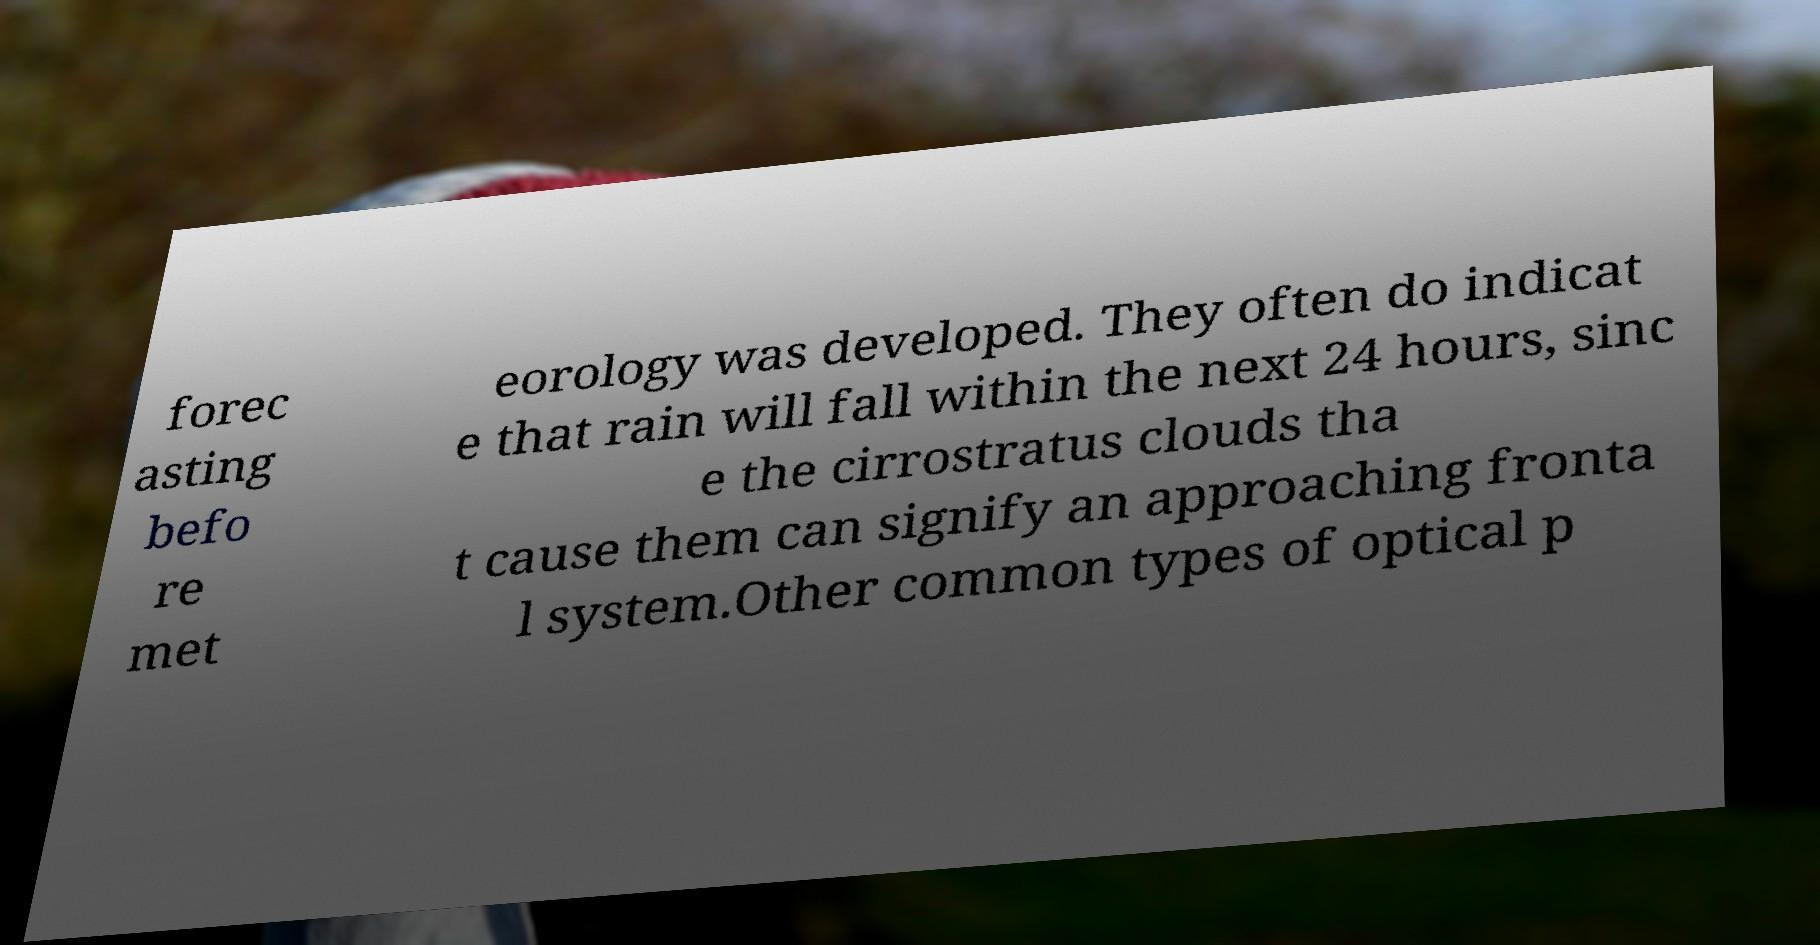Please read and relay the text visible in this image. What does it say? forec asting befo re met eorology was developed. They often do indicat e that rain will fall within the next 24 hours, sinc e the cirrostratus clouds tha t cause them can signify an approaching fronta l system.Other common types of optical p 